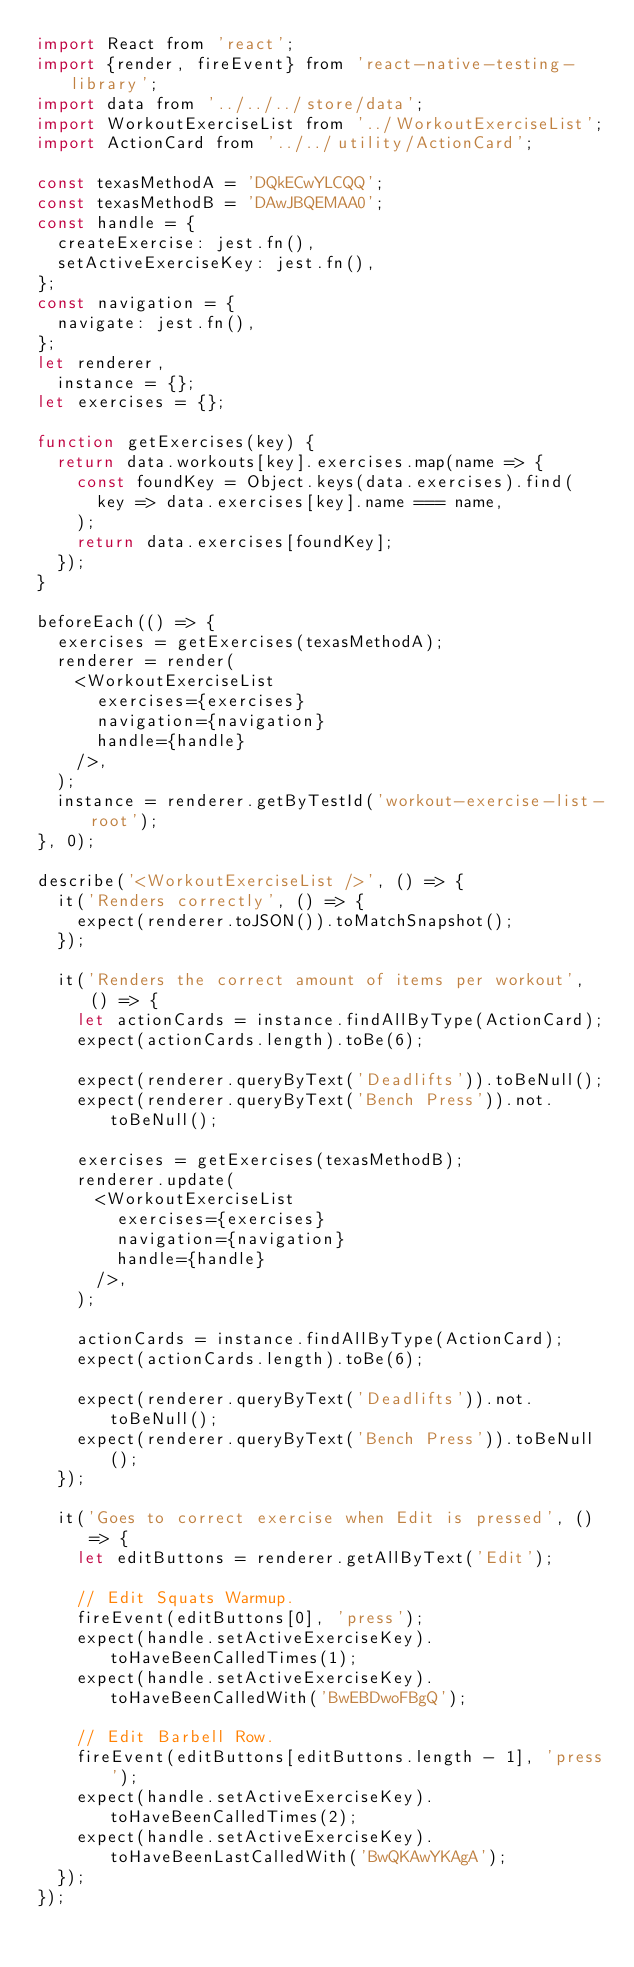<code> <loc_0><loc_0><loc_500><loc_500><_JavaScript_>import React from 'react';
import {render, fireEvent} from 'react-native-testing-library';
import data from '../../../store/data';
import WorkoutExerciseList from '../WorkoutExerciseList';
import ActionCard from '../../utility/ActionCard';

const texasMethodA = 'DQkECwYLCQQ';
const texasMethodB = 'DAwJBQEMAA0';
const handle = {
  createExercise: jest.fn(),
  setActiveExerciseKey: jest.fn(),
};
const navigation = {
  navigate: jest.fn(),
};
let renderer,
  instance = {};
let exercises = {};

function getExercises(key) {
  return data.workouts[key].exercises.map(name => {
    const foundKey = Object.keys(data.exercises).find(
      key => data.exercises[key].name === name,
    );
    return data.exercises[foundKey];
  });
}

beforeEach(() => {
  exercises = getExercises(texasMethodA);
  renderer = render(
    <WorkoutExerciseList
      exercises={exercises}
      navigation={navigation}
      handle={handle}
    />,
  );
  instance = renderer.getByTestId('workout-exercise-list-root');
}, 0);

describe('<WorkoutExerciseList />', () => {
  it('Renders correctly', () => {
    expect(renderer.toJSON()).toMatchSnapshot();
  });

  it('Renders the correct amount of items per workout', () => {
    let actionCards = instance.findAllByType(ActionCard);
    expect(actionCards.length).toBe(6);

    expect(renderer.queryByText('Deadlifts')).toBeNull();
    expect(renderer.queryByText('Bench Press')).not.toBeNull();

    exercises = getExercises(texasMethodB);
    renderer.update(
      <WorkoutExerciseList
        exercises={exercises}
        navigation={navigation}
        handle={handle}
      />,
    );

    actionCards = instance.findAllByType(ActionCard);
    expect(actionCards.length).toBe(6);

    expect(renderer.queryByText('Deadlifts')).not.toBeNull();
    expect(renderer.queryByText('Bench Press')).toBeNull();
  });

  it('Goes to correct exercise when Edit is pressed', () => {
    let editButtons = renderer.getAllByText('Edit');

    // Edit Squats Warmup.
    fireEvent(editButtons[0], 'press');
    expect(handle.setActiveExerciseKey).toHaveBeenCalledTimes(1);
    expect(handle.setActiveExerciseKey).toHaveBeenCalledWith('BwEBDwoFBgQ');

    // Edit Barbell Row.
    fireEvent(editButtons[editButtons.length - 1], 'press');
    expect(handle.setActiveExerciseKey).toHaveBeenCalledTimes(2);
    expect(handle.setActiveExerciseKey).toHaveBeenLastCalledWith('BwQKAwYKAgA');
  });
});
</code> 